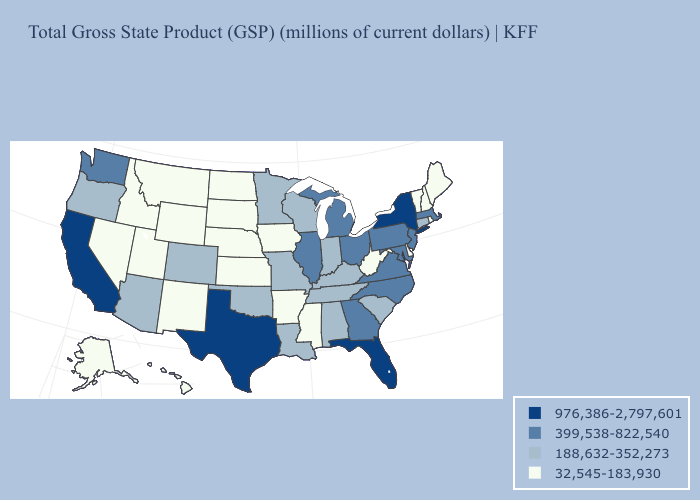Among the states that border Minnesota , does South Dakota have the highest value?
Write a very short answer. No. Does New Jersey have the same value as West Virginia?
Short answer required. No. What is the lowest value in states that border Wisconsin?
Quick response, please. 32,545-183,930. What is the value of Georgia?
Be succinct. 399,538-822,540. What is the highest value in the USA?
Give a very brief answer. 976,386-2,797,601. Name the states that have a value in the range 976,386-2,797,601?
Short answer required. California, Florida, New York, Texas. Name the states that have a value in the range 32,545-183,930?
Concise answer only. Alaska, Arkansas, Delaware, Hawaii, Idaho, Iowa, Kansas, Maine, Mississippi, Montana, Nebraska, Nevada, New Hampshire, New Mexico, North Dakota, Rhode Island, South Dakota, Utah, Vermont, West Virginia, Wyoming. Among the states that border Mississippi , which have the lowest value?
Short answer required. Arkansas. Among the states that border New Jersey , does Delaware have the lowest value?
Write a very short answer. Yes. Among the states that border Maryland , does Delaware have the highest value?
Keep it brief. No. What is the value of Connecticut?
Answer briefly. 188,632-352,273. Among the states that border South Dakota , does Minnesota have the lowest value?
Write a very short answer. No. Name the states that have a value in the range 976,386-2,797,601?
Short answer required. California, Florida, New York, Texas. Does Pennsylvania have the lowest value in the Northeast?
Give a very brief answer. No. Among the states that border Vermont , which have the highest value?
Write a very short answer. New York. 